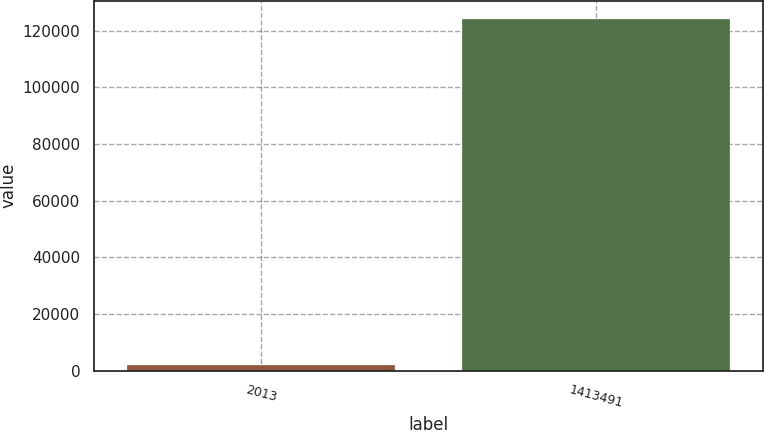<chart> <loc_0><loc_0><loc_500><loc_500><bar_chart><fcel>2013<fcel>1413491<nl><fcel>2013<fcel>124374<nl></chart> 